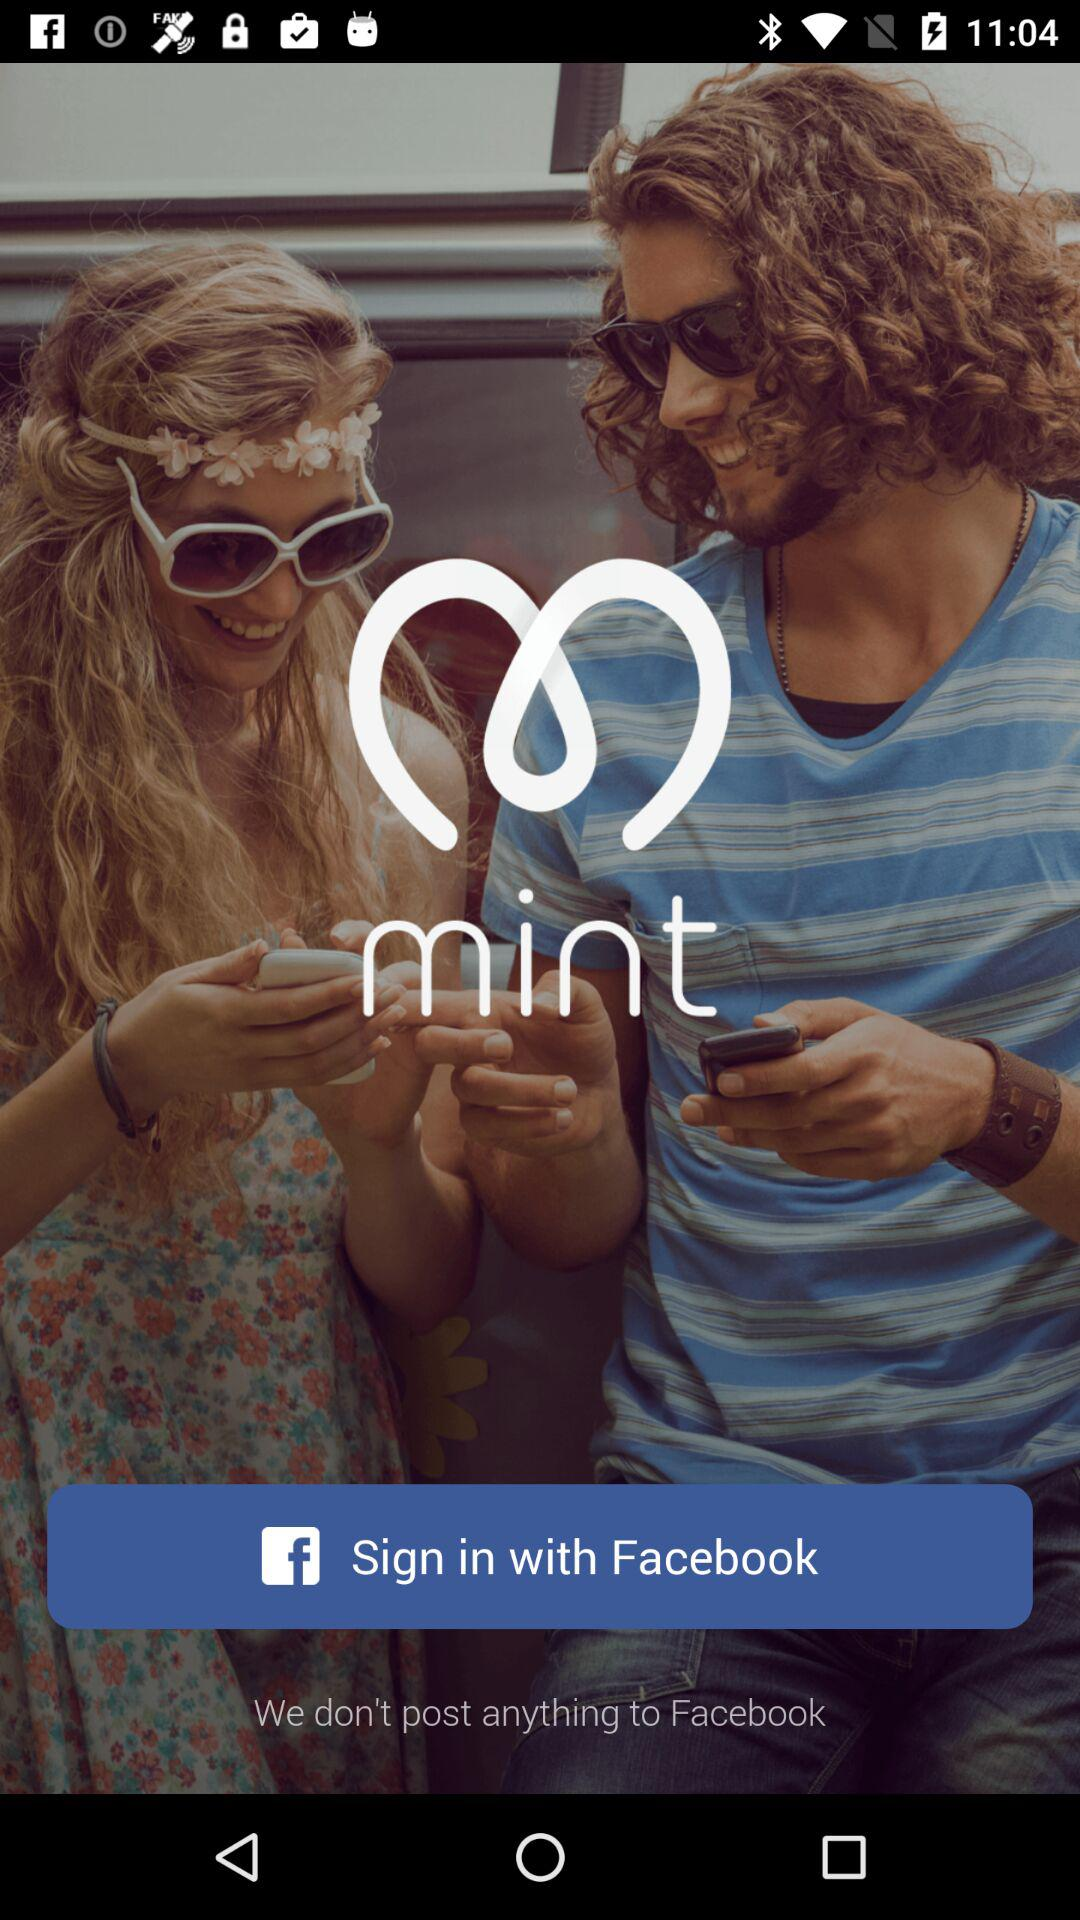What account can be used to sign in? The account is "Facebook". 